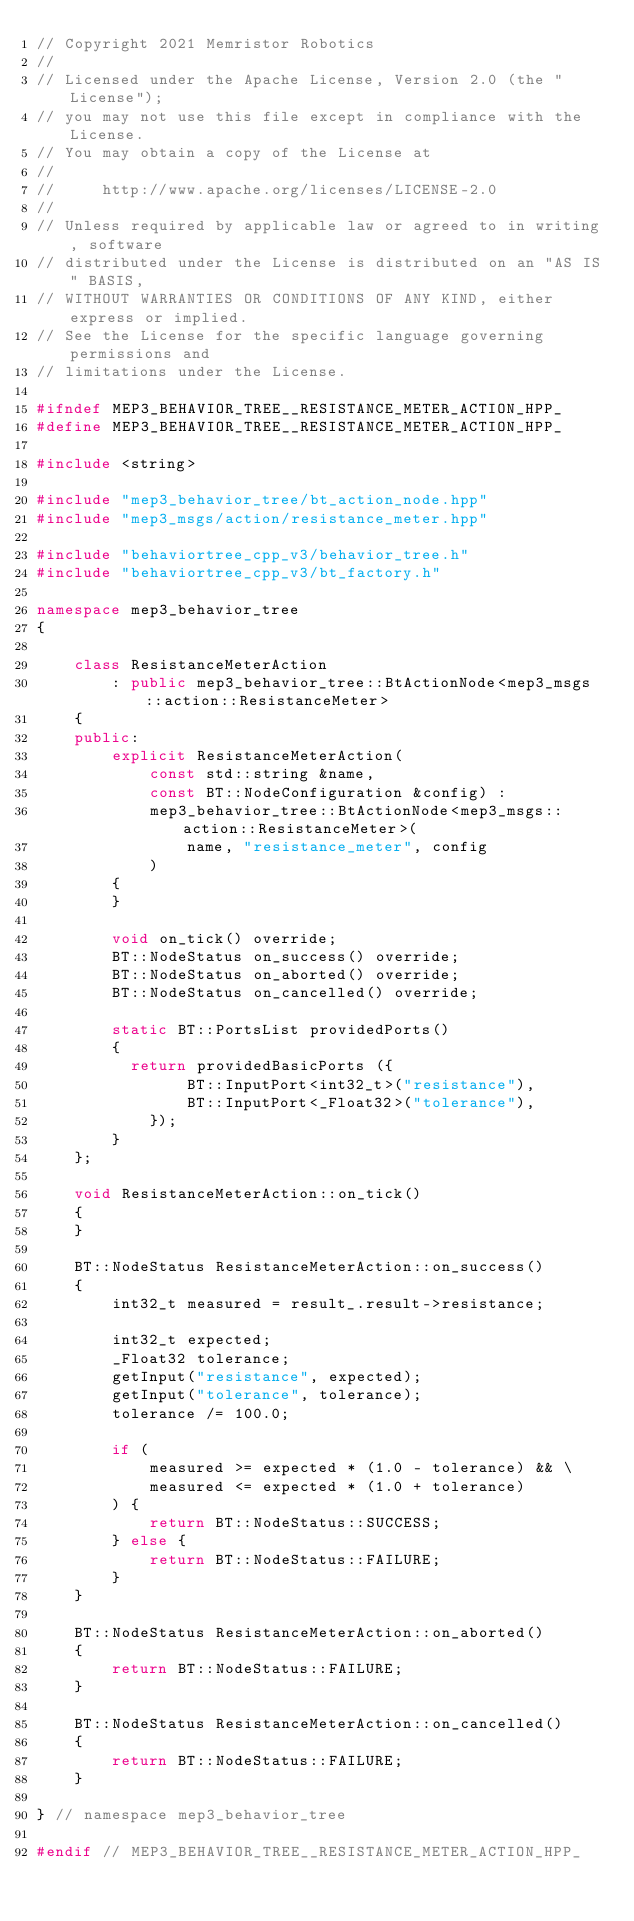<code> <loc_0><loc_0><loc_500><loc_500><_C++_>// Copyright 2021 Memristor Robotics
//
// Licensed under the Apache License, Version 2.0 (the "License");
// you may not use this file except in compliance with the License.
// You may obtain a copy of the License at
//
//     http://www.apache.org/licenses/LICENSE-2.0
//
// Unless required by applicable law or agreed to in writing, software
// distributed under the License is distributed on an "AS IS" BASIS,
// WITHOUT WARRANTIES OR CONDITIONS OF ANY KIND, either express or implied.
// See the License for the specific language governing permissions and
// limitations under the License.

#ifndef MEP3_BEHAVIOR_TREE__RESISTANCE_METER_ACTION_HPP_
#define MEP3_BEHAVIOR_TREE__RESISTANCE_METER_ACTION_HPP_

#include <string>

#include "mep3_behavior_tree/bt_action_node.hpp"
#include "mep3_msgs/action/resistance_meter.hpp"

#include "behaviortree_cpp_v3/behavior_tree.h"
#include "behaviortree_cpp_v3/bt_factory.h"

namespace mep3_behavior_tree
{

    class ResistanceMeterAction
        : public mep3_behavior_tree::BtActionNode<mep3_msgs::action::ResistanceMeter>
    {
    public:
        explicit ResistanceMeterAction(
            const std::string &name,
            const BT::NodeConfiguration &config) :
            mep3_behavior_tree::BtActionNode<mep3_msgs::action::ResistanceMeter>(
                name, "resistance_meter", config
            )
        {
        }

        void on_tick() override;
        BT::NodeStatus on_success() override;
        BT::NodeStatus on_aborted() override;
        BT::NodeStatus on_cancelled() override;

        static BT::PortsList providedPorts()
        {
          return providedBasicPorts ({
                BT::InputPort<int32_t>("resistance"),
                BT::InputPort<_Float32>("tolerance"),
            });
        }
    };

    void ResistanceMeterAction::on_tick()
    {
    }

    BT::NodeStatus ResistanceMeterAction::on_success()
    {
        int32_t measured = result_.result->resistance;

        int32_t expected;
        _Float32 tolerance;
        getInput("resistance", expected);
        getInput("tolerance", tolerance);
        tolerance /= 100.0;

        if (
            measured >= expected * (1.0 - tolerance) && \
            measured <= expected * (1.0 + tolerance)
        ) {
            return BT::NodeStatus::SUCCESS;
        } else {
            return BT::NodeStatus::FAILURE;
        }
    }

    BT::NodeStatus ResistanceMeterAction::on_aborted()
    {
        return BT::NodeStatus::FAILURE;
    }

    BT::NodeStatus ResistanceMeterAction::on_cancelled()
    {
        return BT::NodeStatus::FAILURE;
    }

} // namespace mep3_behavior_tree

#endif // MEP3_BEHAVIOR_TREE__RESISTANCE_METER_ACTION_HPP_
</code> 